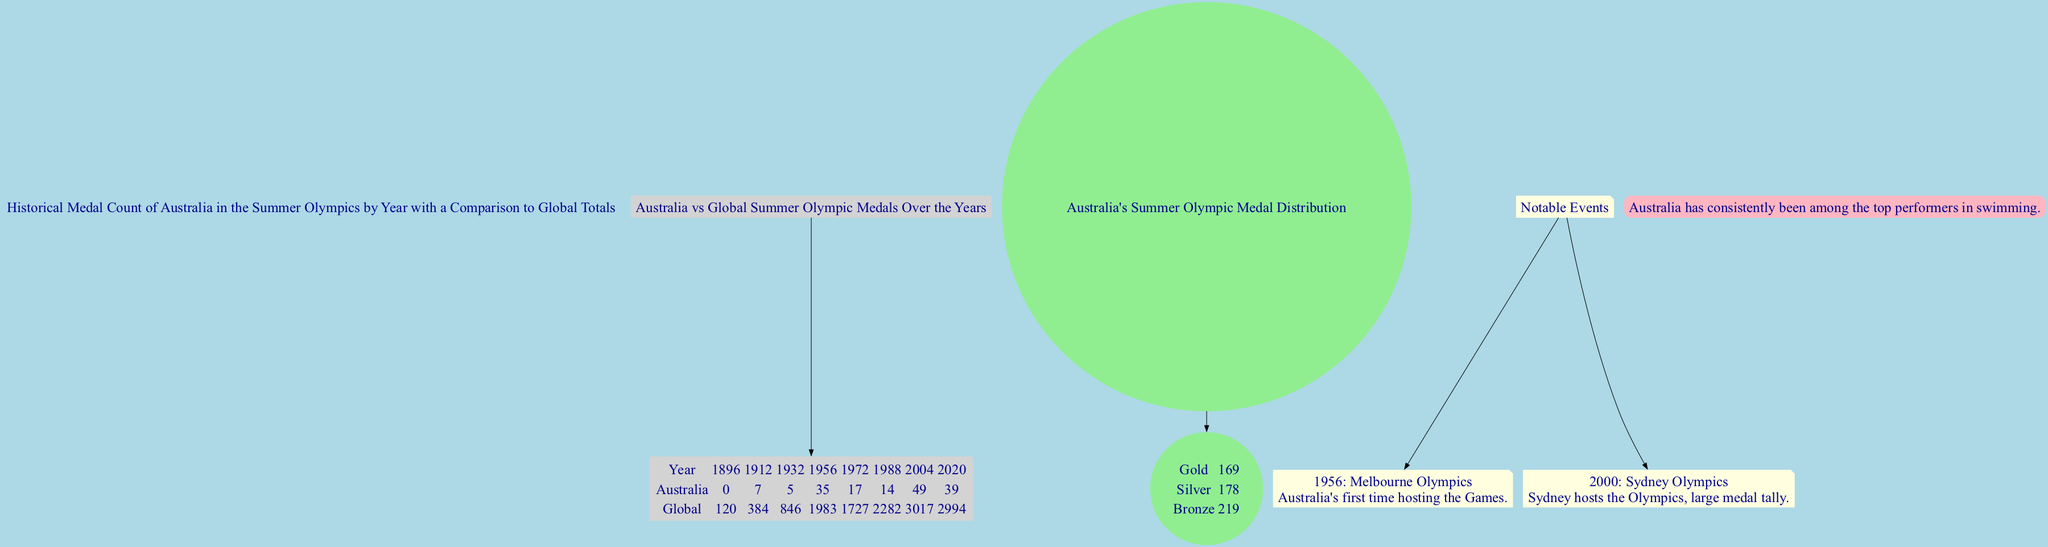What year did Australia win its highest number of medals? Looking at the line graph, the highest point for Australia appears to be in the year 2000, where the medal count peaks.
Answer: 58 Which category of medals has the highest count in Australia's distribution? Referring to the pie chart, Australia has 219 bronze medals, which is greater than the counts of gold and silver medals.
Answer: Bronze In which year did Australia first participate in the Summer Olympics? Based on the x-axis of the line graph, the first year listed is 1896, indicating Australia's first participation.
Answer: 1896 What is the total number of silver medals won by Australia? From the pie chart, the silver medal count shows 178, which directly answers the question about total silver medals.
Answer: 178 During which Olympics did Australia host the Games? The annotations section lists two key events, and the Melbourne Olympics in 1956 is noted specifically as Australia's first time hosting.
Answer: Melbourne Olympics From 2000 to 2020, did the overall medal count for Australia increase or decrease? Comparing the data points in the line graph, in 2000 Australia had 58 medals and by 2020 it had 39, indicating a decrease.
Answer: Decrease How many gold medals has Australia won in total? The pie chart states there are 169 gold medals, directly answering the question about total gold medals.
Answer: 169 Which years indicate significant events for Australia during the Olympics? The annotations detail events for 1956 (Melbourne Olympics) and 2000 (Sydney Olympics) as significant years for Australia.
Answer: 1956, 2000 What was the global total of medals in 1932? Looking at the global data series in the line graph, the value for the year 1932 is 846, which is the total number of global medals for that year.
Answer: 846 